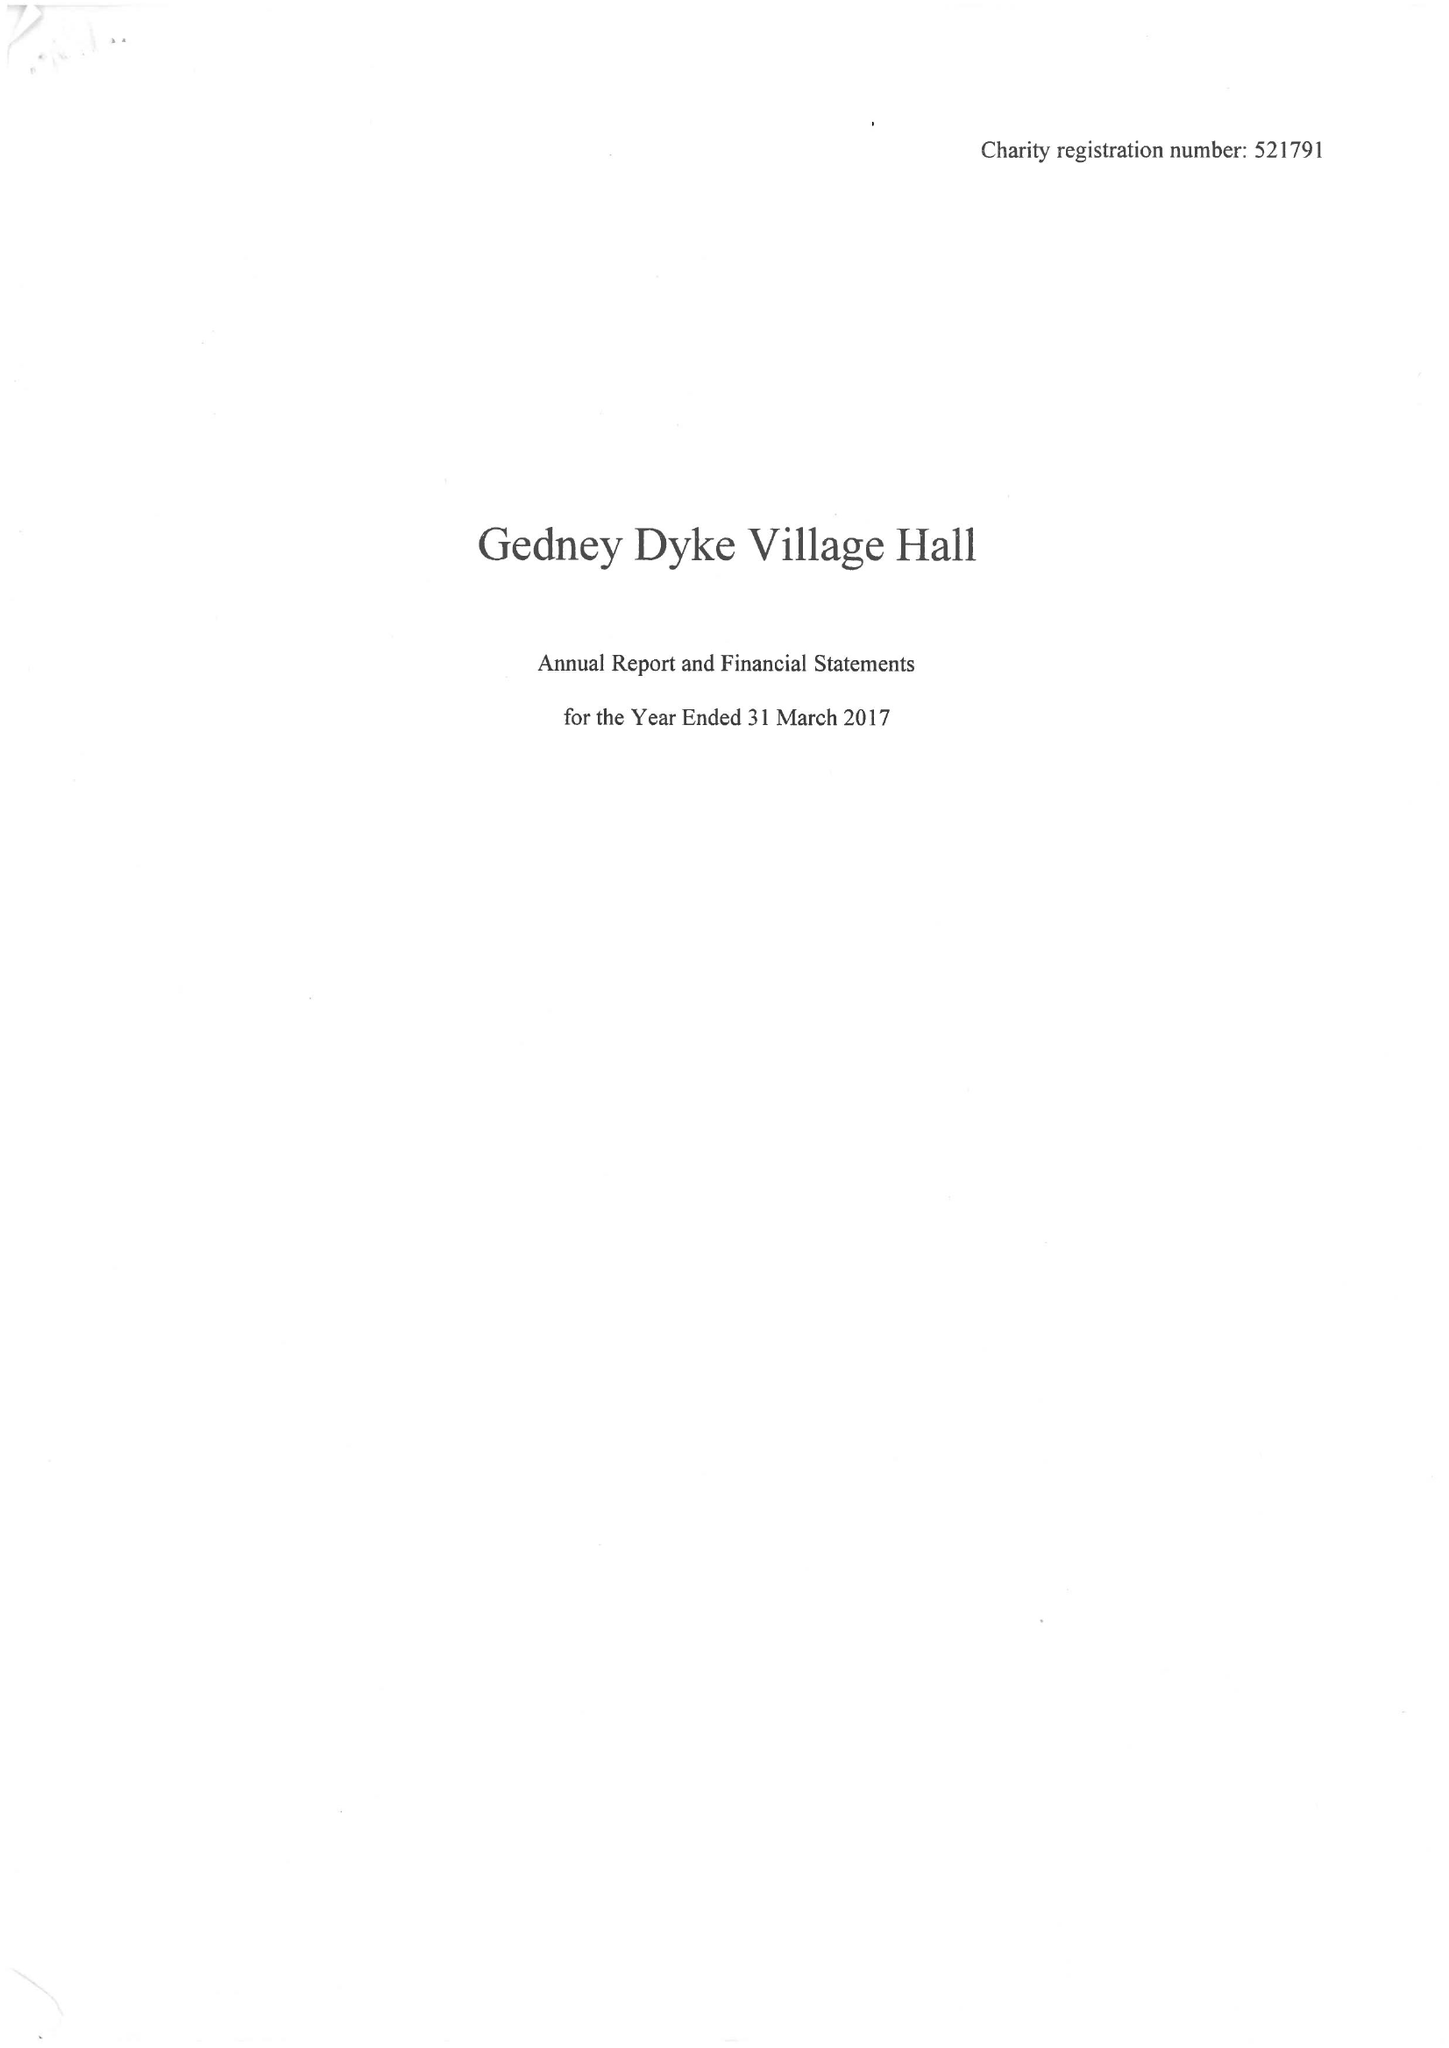What is the value for the charity_number?
Answer the question using a single word or phrase. 521791 